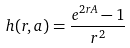Convert formula to latex. <formula><loc_0><loc_0><loc_500><loc_500>h ( r , a ) = \frac { e ^ { 2 r A } - 1 } { r ^ { 2 } }</formula> 